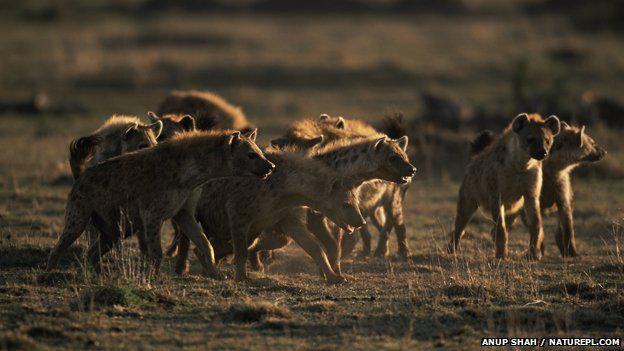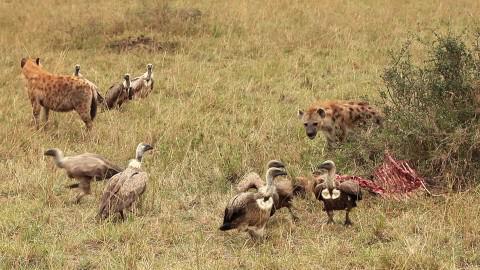The first image is the image on the left, the second image is the image on the right. Given the left and right images, does the statement "An antelope is being attacked in the image on the left." hold true? Answer yes or no. No. 